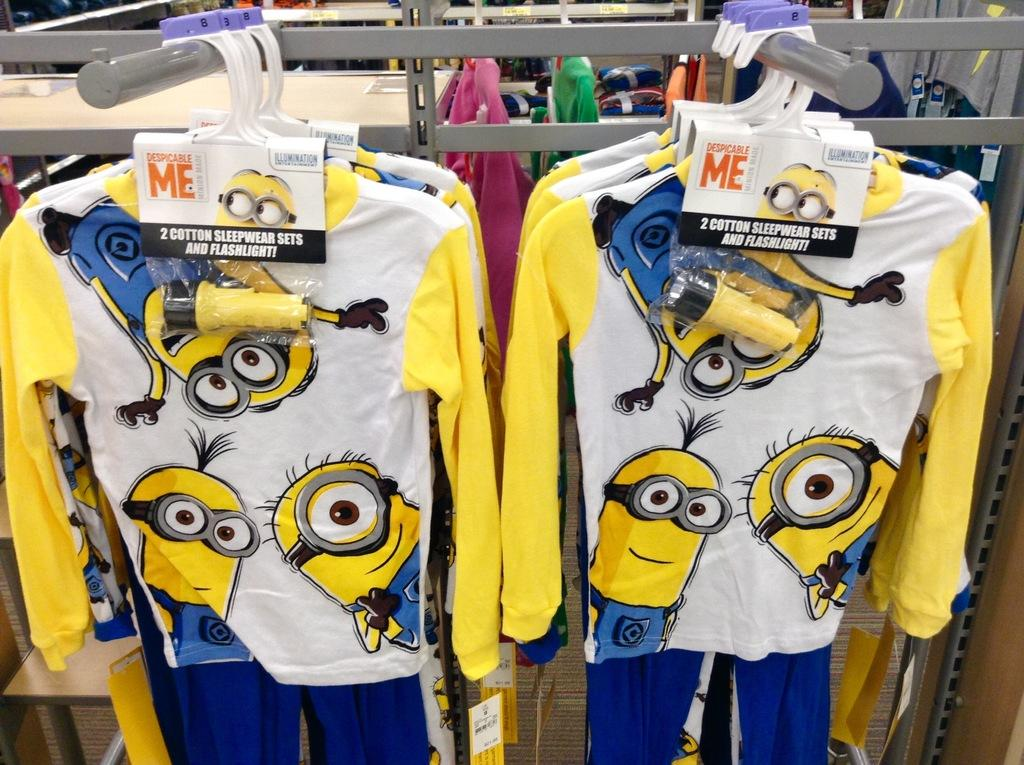<image>
Create a compact narrative representing the image presented. Despicalble Me sleepware sets made of cotton fabric.. 